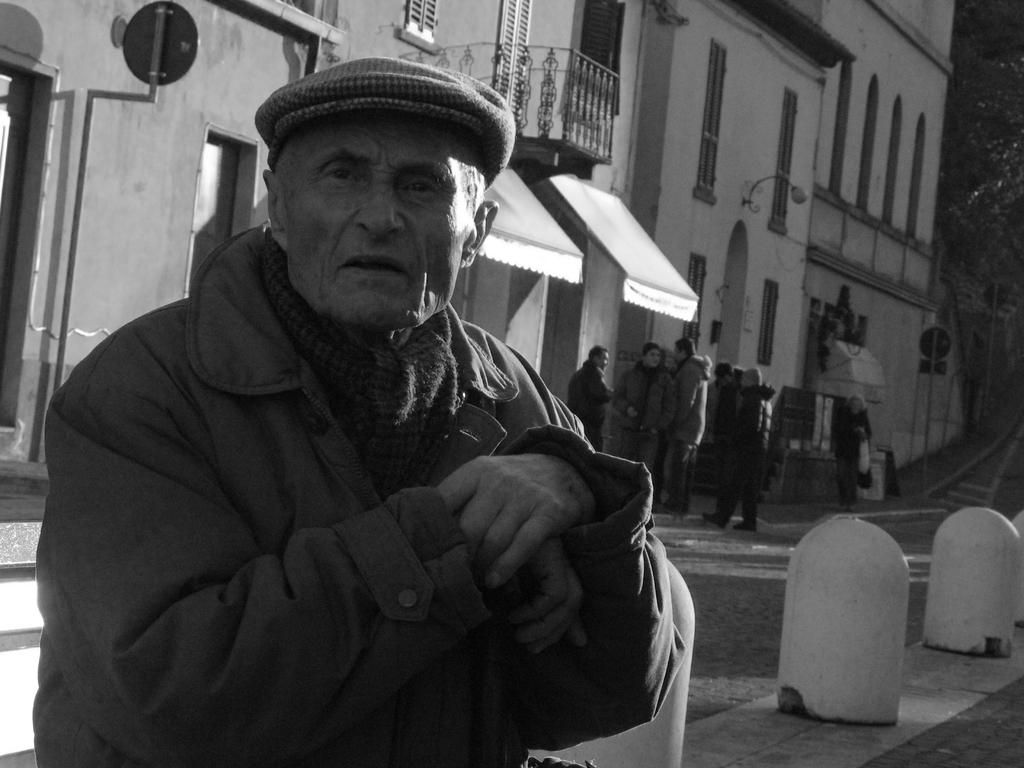Who is the main subject in the image? There is an old man in the image. What is the old man wearing? The old man is wearing a coat. What can be seen in the background of the image? There is a building in the image. What type of cat can be seen playing with a bee near the old man in the image? There is no cat or bee present in the image; it only features an old man and a building in the background. 